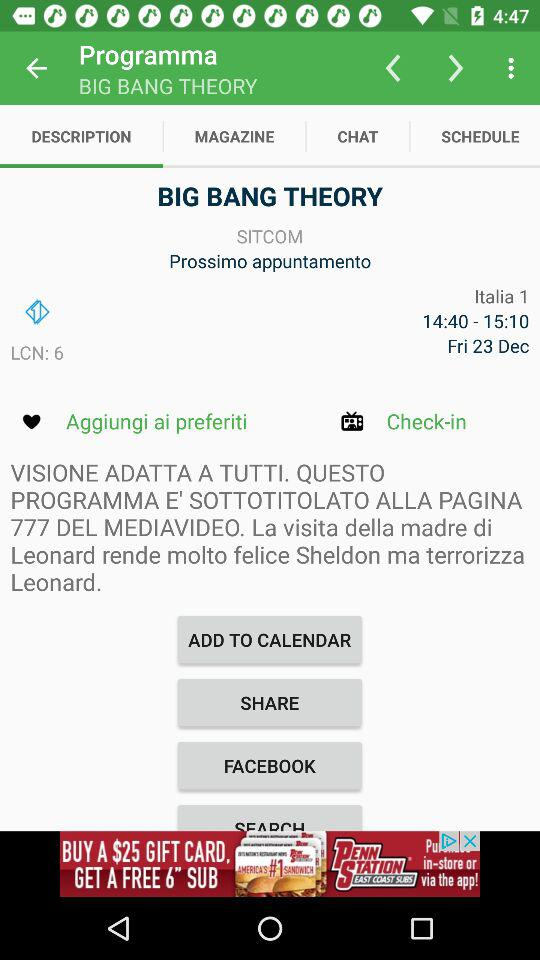Which tab is selected? The selected tab is "DESCRIPTION". 